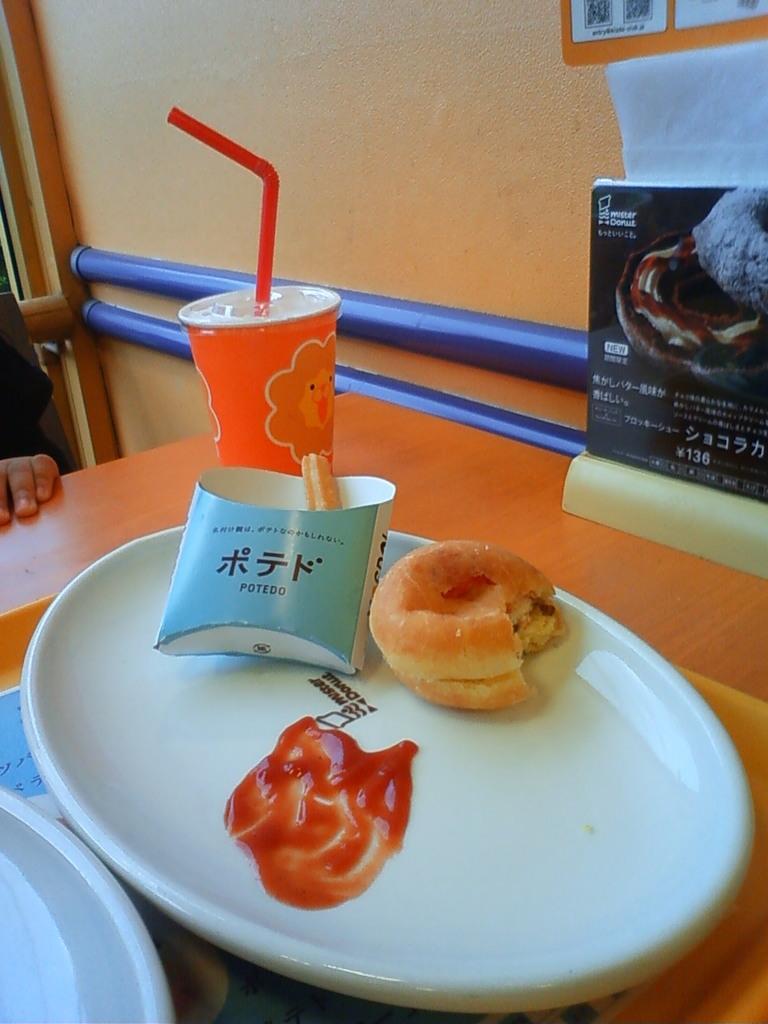Please provide a concise description of this image. In this picture I can see plates on the train, there are food items on one of the plate, there is a paper glass with a straw and there are papers on the table, there is a hand of a person, and in the background there is a wall. 